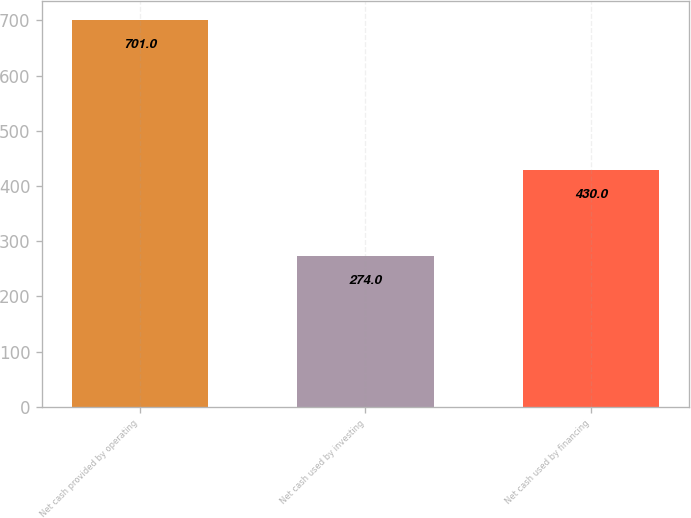Convert chart to OTSL. <chart><loc_0><loc_0><loc_500><loc_500><bar_chart><fcel>Net cash provided by operating<fcel>Net cash used by investing<fcel>Net cash used by financing<nl><fcel>701<fcel>274<fcel>430<nl></chart> 